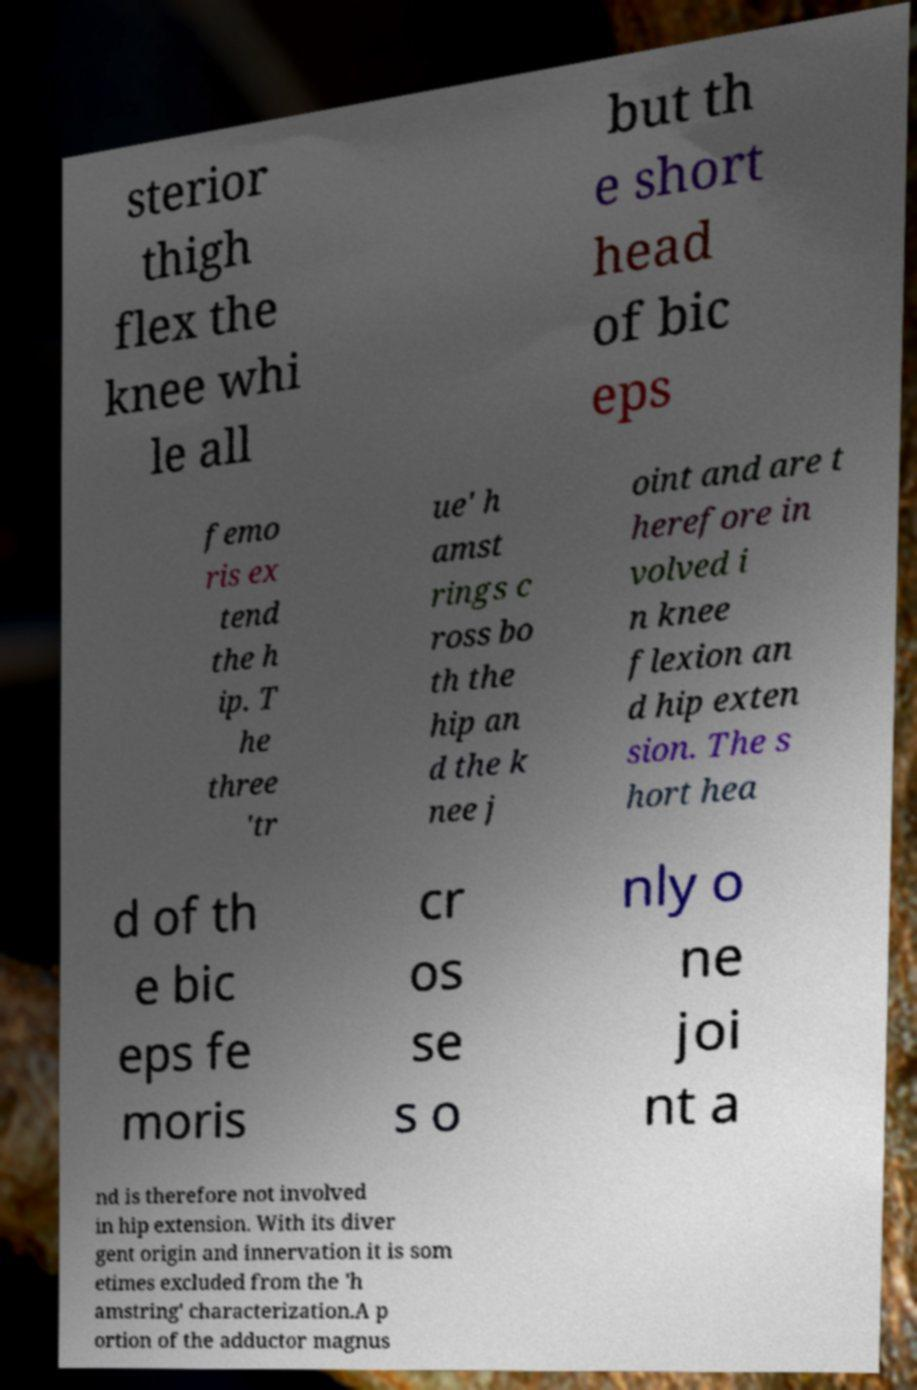Please identify and transcribe the text found in this image. sterior thigh flex the knee whi le all but th e short head of bic eps femo ris ex tend the h ip. T he three 'tr ue' h amst rings c ross bo th the hip an d the k nee j oint and are t herefore in volved i n knee flexion an d hip exten sion. The s hort hea d of th e bic eps fe moris cr os se s o nly o ne joi nt a nd is therefore not involved in hip extension. With its diver gent origin and innervation it is som etimes excluded from the 'h amstring' characterization.A p ortion of the adductor magnus 